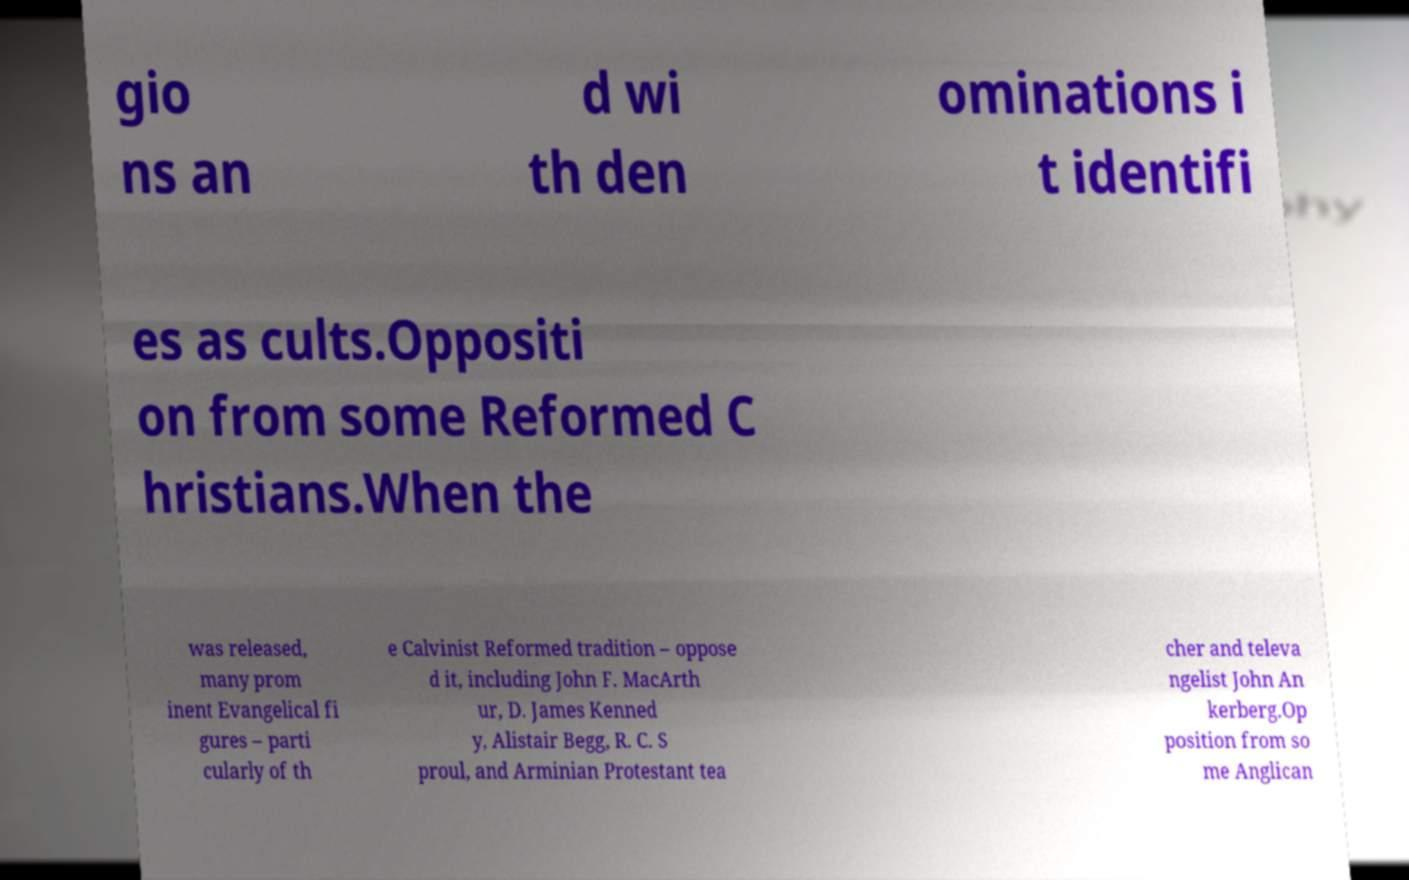Could you extract and type out the text from this image? gio ns an d wi th den ominations i t identifi es as cults.Oppositi on from some Reformed C hristians.When the was released, many prom inent Evangelical fi gures – parti cularly of th e Calvinist Reformed tradition – oppose d it, including John F. MacArth ur, D. James Kenned y, Alistair Begg, R. C. S proul, and Arminian Protestant tea cher and televa ngelist John An kerberg.Op position from so me Anglican 